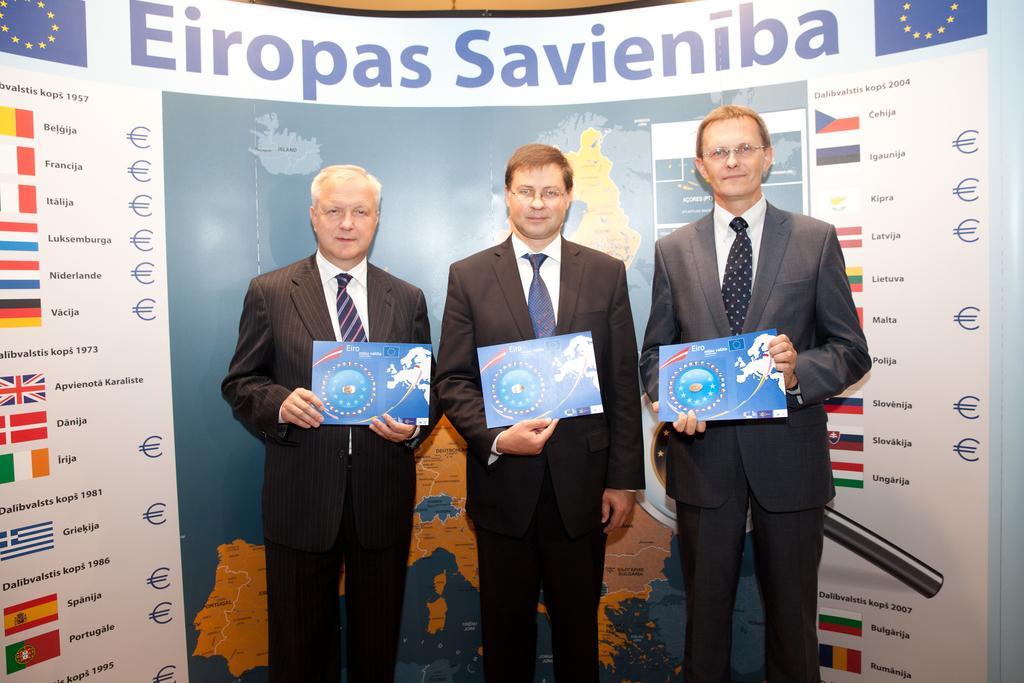Describe this image in one or two sentences. In this picture I can see few men standing holding posters in their hands and i can see a advertisement hoarding on the back with some text and few flags and I can see a map on the hoarding and i can see couple of men wore spectacles and they wore quotes and ties. 